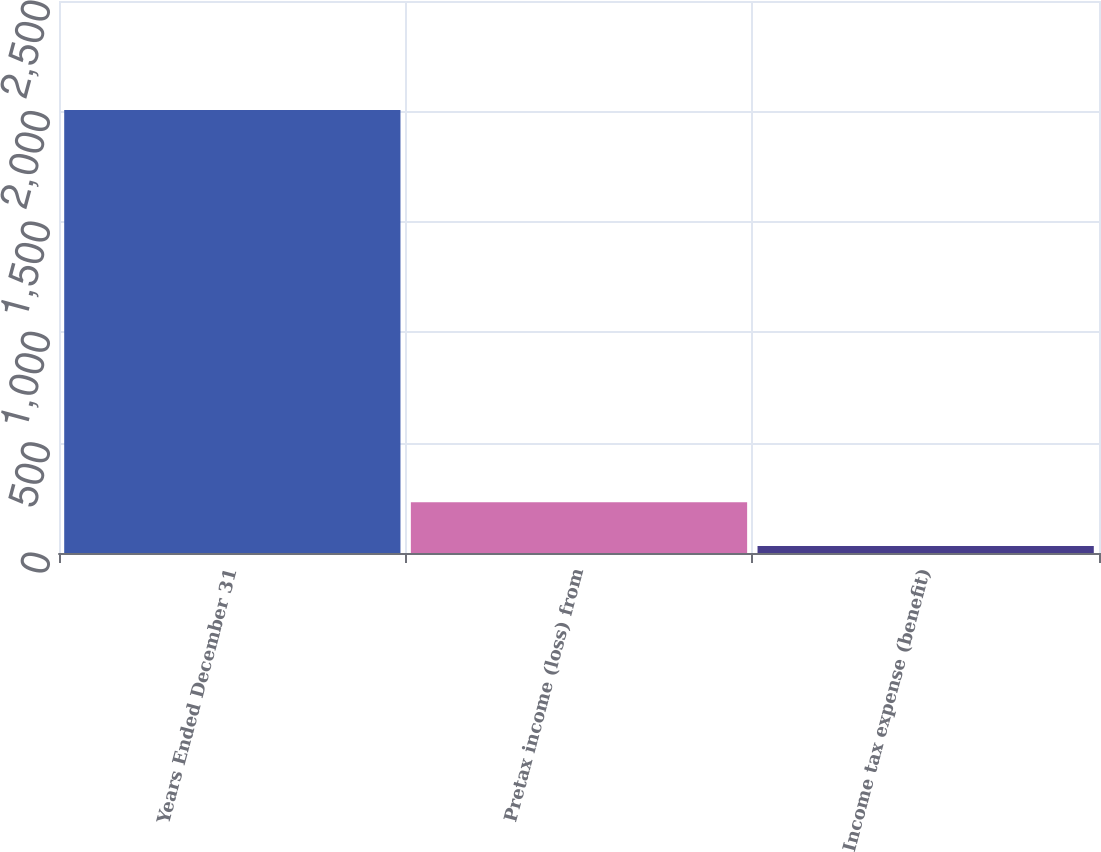<chart> <loc_0><loc_0><loc_500><loc_500><bar_chart><fcel>Years Ended December 31<fcel>Pretax income (loss) from<fcel>Income tax expense (benefit)<nl><fcel>2006<fcel>229.4<fcel>32<nl></chart> 